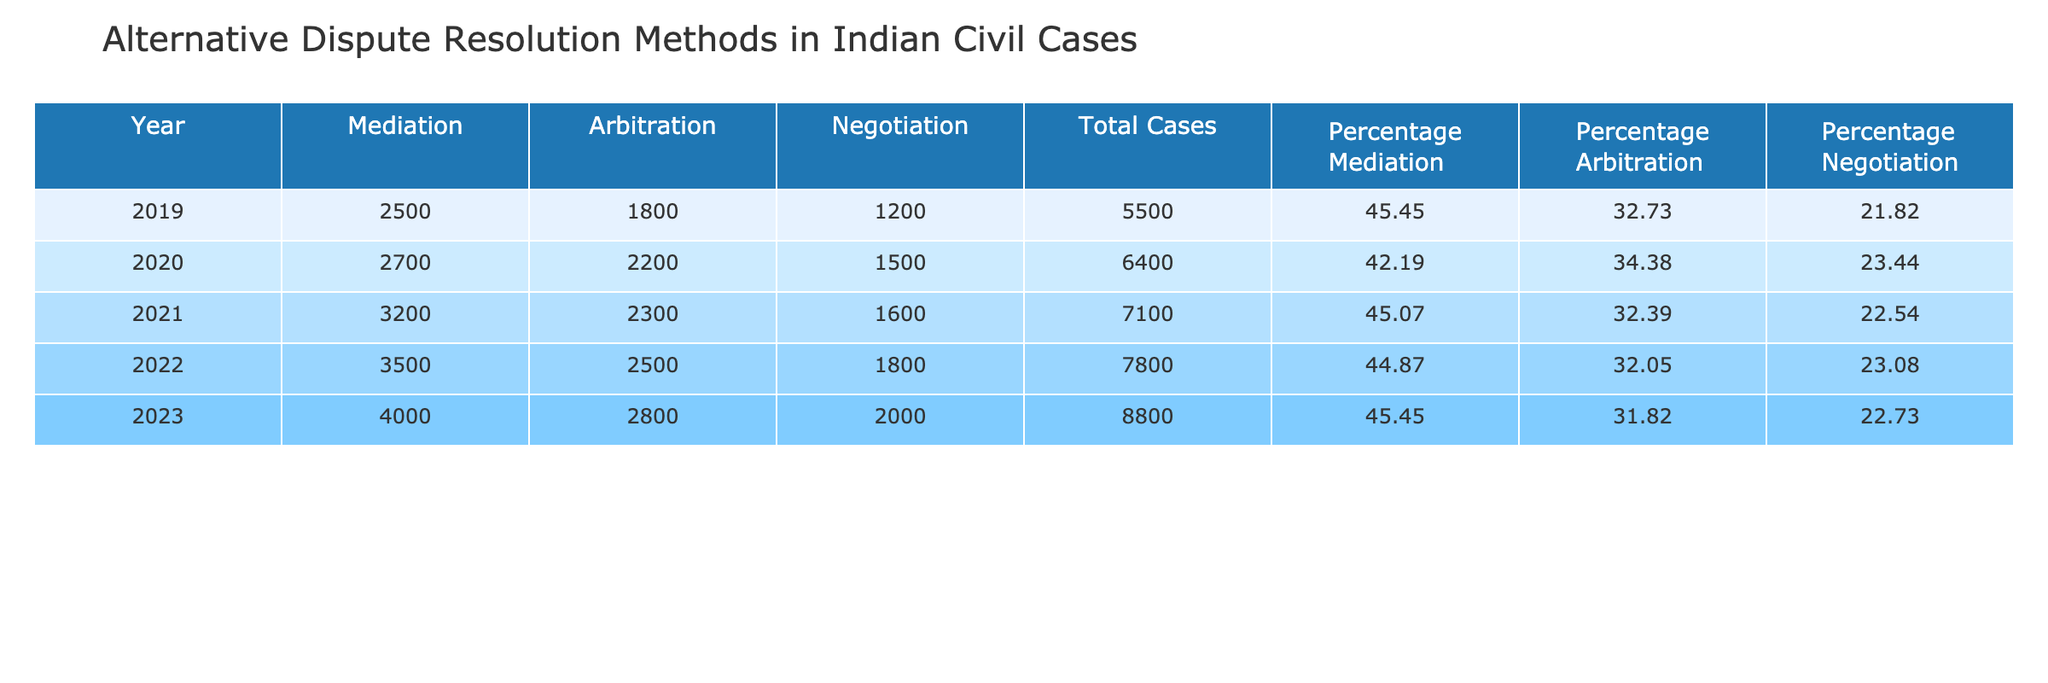What was the total number of civil cases in India in 2022? The table shows the total number of civil cases for each year in the "Total Cases" column. The value for the year 2022 is 7800.
Answer: 7800 What percentage of cases in 2020 used mediation? In 2020, the percentage of cases that used mediation is provided in the "Percentage Mediation" column. The value for 2020 is 42.19%.
Answer: 42.19% Which alternative dispute resolution method had the highest number of cases in 2023? Looking at the "Mediation", "Arbitration", and "Negotiation" columns for 2023, we see that mediation had the highest number of cases at 4000.
Answer: Mediation What was the increase in the number of mediation cases from 2019 to 2021? The number of mediation cases in 2019 is 2500, and in 2021 it is 3200. Calculating the increase gives us 3200 - 2500 = 700 cases.
Answer: 700 In which year did arbitration reach its highest number of cases, and what was that number? By reviewing the "Arbitration" column, we identify that the year 2020 had the highest number of cases at 2200.
Answer: 2020, 2200 Is the percentage of negotiation cases consistently higher than those of arbitration for all years? Comparing the "Percentage Negotiation" and "Percentage Arbitration" columns across all years, negotiation does not consistently have a higher percentage than arbitration; hence the statement is false.
Answer: No What is the average number of negotiation cases across the years 2019 to 2023? To find the average, we sum the negotiation cases: (1200 + 1500 + 1600 + 1800 + 2000) = 9100. Then, we divide by the number of years, which is 5: 9100 / 5 = 1820.
Answer: 1820 What was the trend in the percentage of arbitration cases from 2019 to 2023? By examining the "Percentage Arbitration" column from 2019 to 2023, we see that the percentage has slightly decreased: 32.73%, 34.38%, 32.39%, 32.05%, 31.82%. This indicates a downward trend.
Answer: Decreasing trend What is the total number of alternative dispute resolution cases across all methods in 2022? The total for all methods in 2022 is found by adding the values from the "Mediation", "Arbitration", and "Negotiation" columns for that year: 3500 + 2500 + 1800 = 7800.
Answer: 7800 